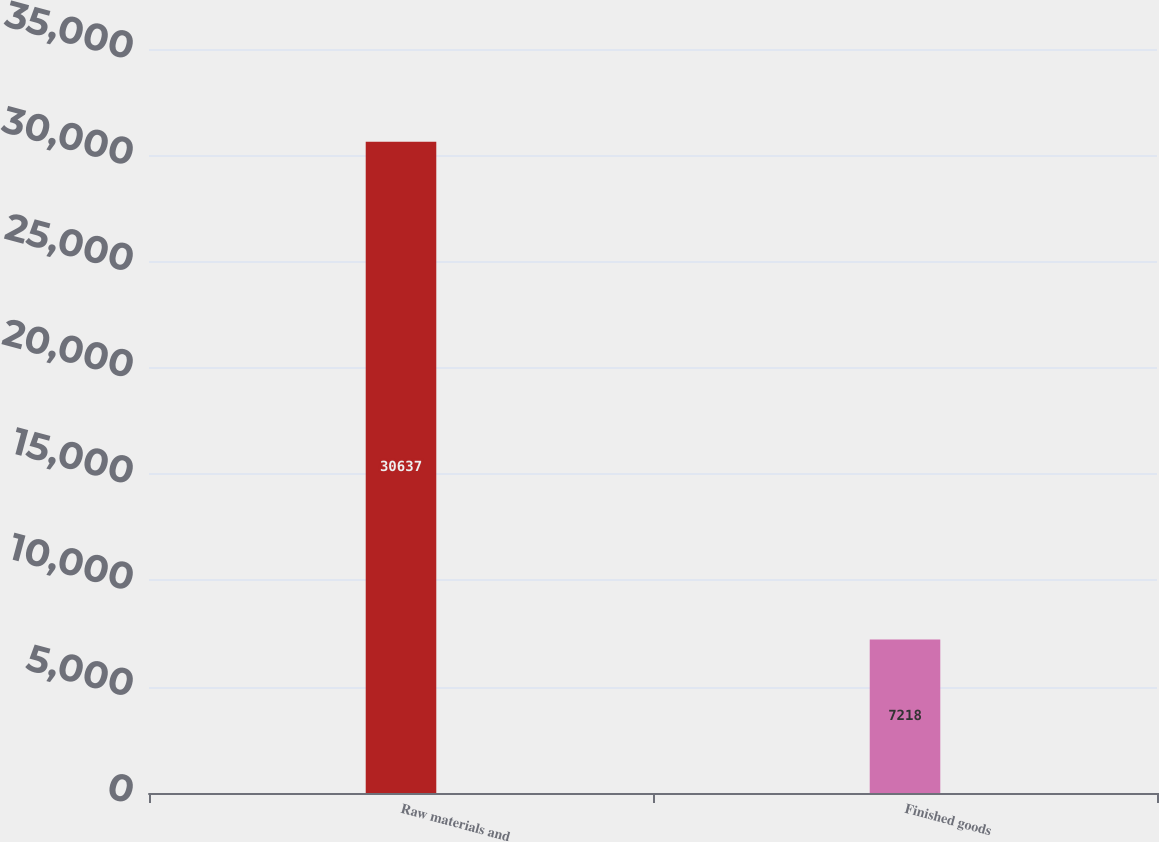<chart> <loc_0><loc_0><loc_500><loc_500><bar_chart><fcel>Raw materials and<fcel>Finished goods<nl><fcel>30637<fcel>7218<nl></chart> 